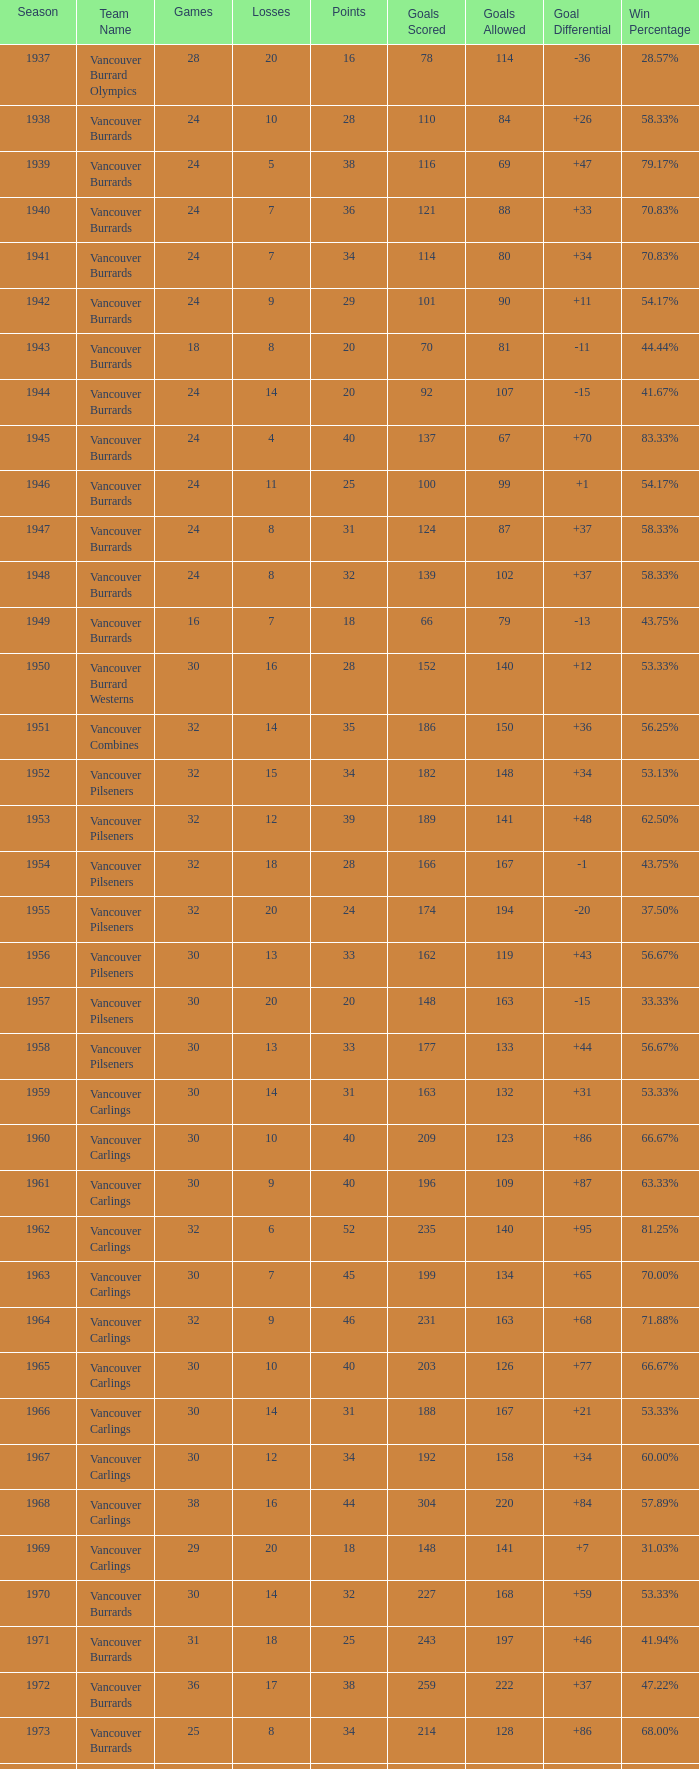What's the total number of points when the vancouver burrards have fewer than 9 losses and more than 24 games? 1.0. 